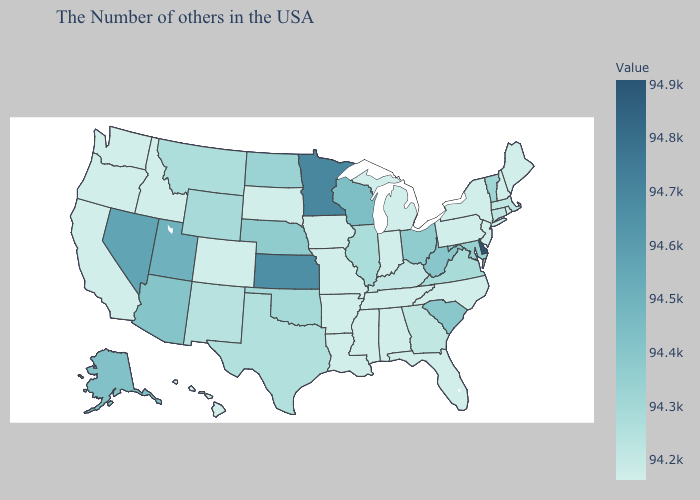Among the states that border Kentucky , which have the highest value?
Give a very brief answer. West Virginia. Does Delaware have the highest value in the USA?
Quick response, please. Yes. Which states have the lowest value in the USA?
Keep it brief. Maine, Rhode Island, New Hampshire, New York, New Jersey, Pennsylvania, North Carolina, Florida, Michigan, Indiana, Alabama, Tennessee, Mississippi, Louisiana, Missouri, Arkansas, Iowa, South Dakota, Colorado, Idaho, California, Washington, Oregon, Hawaii. Among the states that border New York , which have the highest value?
Give a very brief answer. Vermont. Which states have the highest value in the USA?
Be succinct. Delaware. Is the legend a continuous bar?
Write a very short answer. Yes. Which states have the highest value in the USA?
Quick response, please. Delaware. Among the states that border Pennsylvania , does Maryland have the lowest value?
Be succinct. No. 